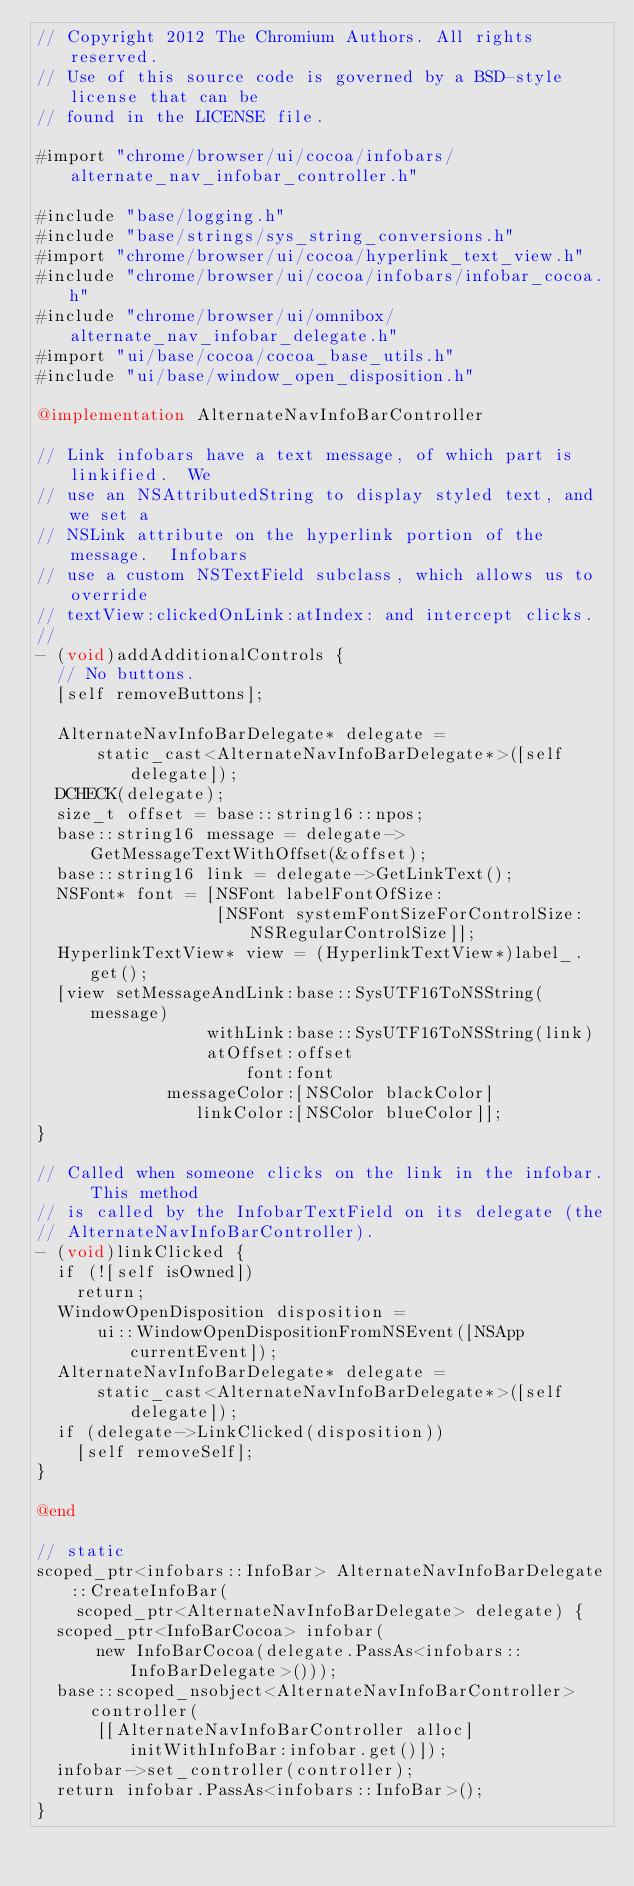Convert code to text. <code><loc_0><loc_0><loc_500><loc_500><_ObjectiveC_>// Copyright 2012 The Chromium Authors. All rights reserved.
// Use of this source code is governed by a BSD-style license that can be
// found in the LICENSE file.

#import "chrome/browser/ui/cocoa/infobars/alternate_nav_infobar_controller.h"

#include "base/logging.h"
#include "base/strings/sys_string_conversions.h"
#import "chrome/browser/ui/cocoa/hyperlink_text_view.h"
#include "chrome/browser/ui/cocoa/infobars/infobar_cocoa.h"
#include "chrome/browser/ui/omnibox/alternate_nav_infobar_delegate.h"
#import "ui/base/cocoa/cocoa_base_utils.h"
#include "ui/base/window_open_disposition.h"

@implementation AlternateNavInfoBarController

// Link infobars have a text message, of which part is linkified.  We
// use an NSAttributedString to display styled text, and we set a
// NSLink attribute on the hyperlink portion of the message.  Infobars
// use a custom NSTextField subclass, which allows us to override
// textView:clickedOnLink:atIndex: and intercept clicks.
//
- (void)addAdditionalControls {
  // No buttons.
  [self removeButtons];

  AlternateNavInfoBarDelegate* delegate =
      static_cast<AlternateNavInfoBarDelegate*>([self delegate]);
  DCHECK(delegate);
  size_t offset = base::string16::npos;
  base::string16 message = delegate->GetMessageTextWithOffset(&offset);
  base::string16 link = delegate->GetLinkText();
  NSFont* font = [NSFont labelFontOfSize:
                  [NSFont systemFontSizeForControlSize:NSRegularControlSize]];
  HyperlinkTextView* view = (HyperlinkTextView*)label_.get();
  [view setMessageAndLink:base::SysUTF16ToNSString(message)
                 withLink:base::SysUTF16ToNSString(link)
                 atOffset:offset
                     font:font
             messageColor:[NSColor blackColor]
                linkColor:[NSColor blueColor]];
}

// Called when someone clicks on the link in the infobar.  This method
// is called by the InfobarTextField on its delegate (the
// AlternateNavInfoBarController).
- (void)linkClicked {
  if (![self isOwned])
    return;
  WindowOpenDisposition disposition =
      ui::WindowOpenDispositionFromNSEvent([NSApp currentEvent]);
  AlternateNavInfoBarDelegate* delegate =
      static_cast<AlternateNavInfoBarDelegate*>([self delegate]);
  if (delegate->LinkClicked(disposition))
    [self removeSelf];
}

@end

// static
scoped_ptr<infobars::InfoBar> AlternateNavInfoBarDelegate::CreateInfoBar(
    scoped_ptr<AlternateNavInfoBarDelegate> delegate) {
  scoped_ptr<InfoBarCocoa> infobar(
      new InfoBarCocoa(delegate.PassAs<infobars::InfoBarDelegate>()));
  base::scoped_nsobject<AlternateNavInfoBarController> controller(
      [[AlternateNavInfoBarController alloc] initWithInfoBar:infobar.get()]);
  infobar->set_controller(controller);
  return infobar.PassAs<infobars::InfoBar>();
}
</code> 